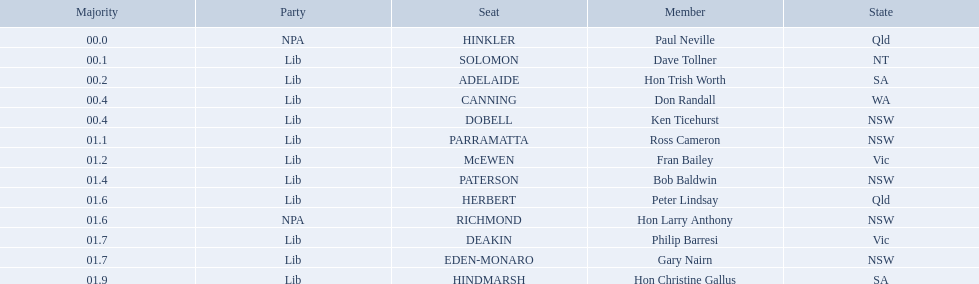Which seats are represented in the electoral system of australia? HINKLER, SOLOMON, ADELAIDE, CANNING, DOBELL, PARRAMATTA, McEWEN, PATERSON, HERBERT, RICHMOND, DEAKIN, EDEN-MONARO, HINDMARSH. What were their majority numbers of both hindmarsh and hinkler? HINKLER, HINDMARSH. Of those two seats, what is the difference in voting majority? 01.9. 